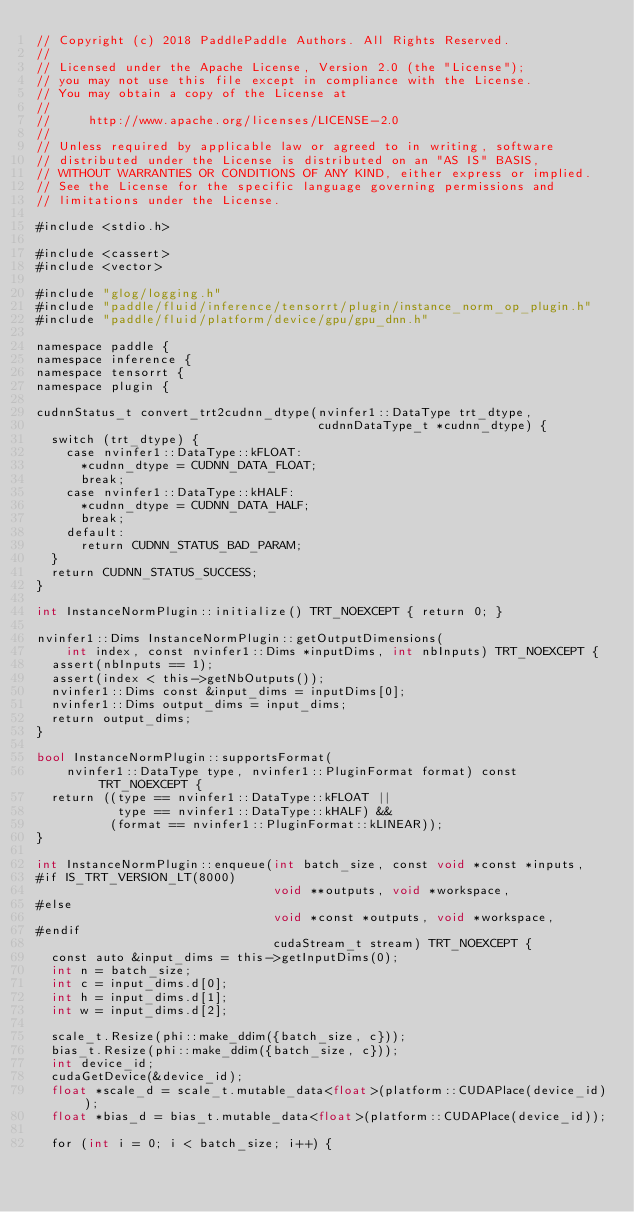Convert code to text. <code><loc_0><loc_0><loc_500><loc_500><_Cuda_>// Copyright (c) 2018 PaddlePaddle Authors. All Rights Reserved.
//
// Licensed under the Apache License, Version 2.0 (the "License");
// you may not use this file except in compliance with the License.
// You may obtain a copy of the License at
//
//     http://www.apache.org/licenses/LICENSE-2.0
//
// Unless required by applicable law or agreed to in writing, software
// distributed under the License is distributed on an "AS IS" BASIS,
// WITHOUT WARRANTIES OR CONDITIONS OF ANY KIND, either express or implied.
// See the License for the specific language governing permissions and
// limitations under the License.

#include <stdio.h>

#include <cassert>
#include <vector>

#include "glog/logging.h"
#include "paddle/fluid/inference/tensorrt/plugin/instance_norm_op_plugin.h"
#include "paddle/fluid/platform/device/gpu/gpu_dnn.h"

namespace paddle {
namespace inference {
namespace tensorrt {
namespace plugin {

cudnnStatus_t convert_trt2cudnn_dtype(nvinfer1::DataType trt_dtype,
                                      cudnnDataType_t *cudnn_dtype) {
  switch (trt_dtype) {
    case nvinfer1::DataType::kFLOAT:
      *cudnn_dtype = CUDNN_DATA_FLOAT;
      break;
    case nvinfer1::DataType::kHALF:
      *cudnn_dtype = CUDNN_DATA_HALF;
      break;
    default:
      return CUDNN_STATUS_BAD_PARAM;
  }
  return CUDNN_STATUS_SUCCESS;
}

int InstanceNormPlugin::initialize() TRT_NOEXCEPT { return 0; }

nvinfer1::Dims InstanceNormPlugin::getOutputDimensions(
    int index, const nvinfer1::Dims *inputDims, int nbInputs) TRT_NOEXCEPT {
  assert(nbInputs == 1);
  assert(index < this->getNbOutputs());
  nvinfer1::Dims const &input_dims = inputDims[0];
  nvinfer1::Dims output_dims = input_dims;
  return output_dims;
}

bool InstanceNormPlugin::supportsFormat(
    nvinfer1::DataType type, nvinfer1::PluginFormat format) const TRT_NOEXCEPT {
  return ((type == nvinfer1::DataType::kFLOAT ||
           type == nvinfer1::DataType::kHALF) &&
          (format == nvinfer1::PluginFormat::kLINEAR));
}

int InstanceNormPlugin::enqueue(int batch_size, const void *const *inputs,
#if IS_TRT_VERSION_LT(8000)
                                void **outputs, void *workspace,
#else
                                void *const *outputs, void *workspace,
#endif
                                cudaStream_t stream) TRT_NOEXCEPT {
  const auto &input_dims = this->getInputDims(0);
  int n = batch_size;
  int c = input_dims.d[0];
  int h = input_dims.d[1];
  int w = input_dims.d[2];

  scale_t.Resize(phi::make_ddim({batch_size, c}));
  bias_t.Resize(phi::make_ddim({batch_size, c}));
  int device_id;
  cudaGetDevice(&device_id);
  float *scale_d = scale_t.mutable_data<float>(platform::CUDAPlace(device_id));
  float *bias_d = bias_t.mutable_data<float>(platform::CUDAPlace(device_id));

  for (int i = 0; i < batch_size; i++) {</code> 